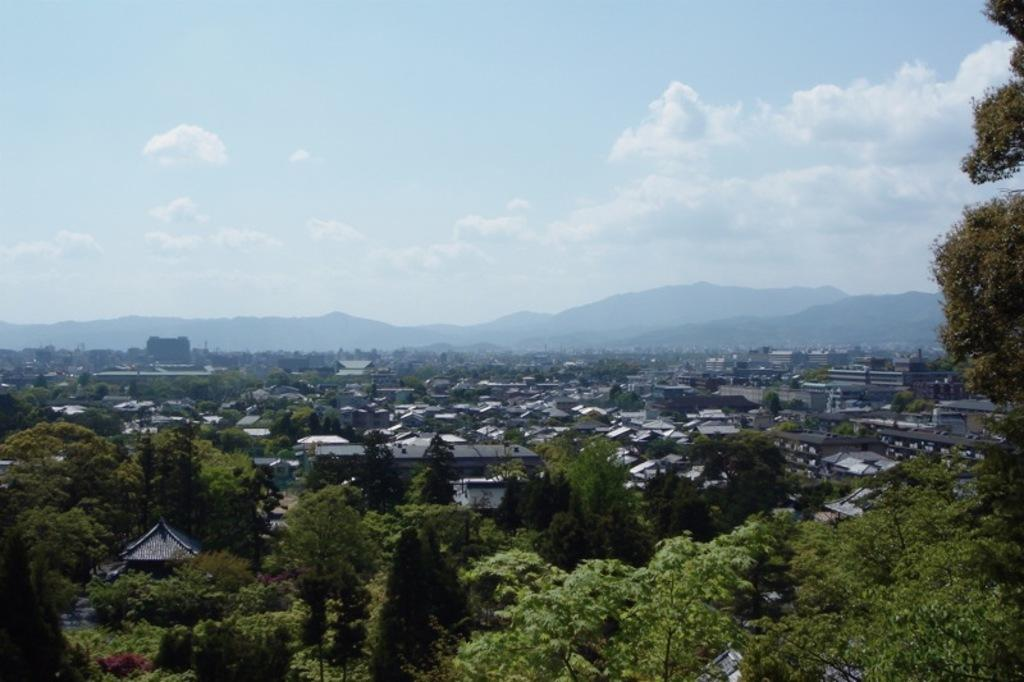What type of natural formation can be seen in the image? There are mountains in the image. What type of man-made structures are present in the image? There are buildings in the image. What type of vegetation is present in the image? There are trees in the image. What is visible in the background of the image? The sky is visible in the background of the image. What is the weather like in the image? The sky is cloudy in the image. What type of stem can be seen growing from the mountains in the image? There is no stem growing from the mountains in the image. How many strings are attached to the buildings in the image? There are no strings attached to the buildings in the image. 